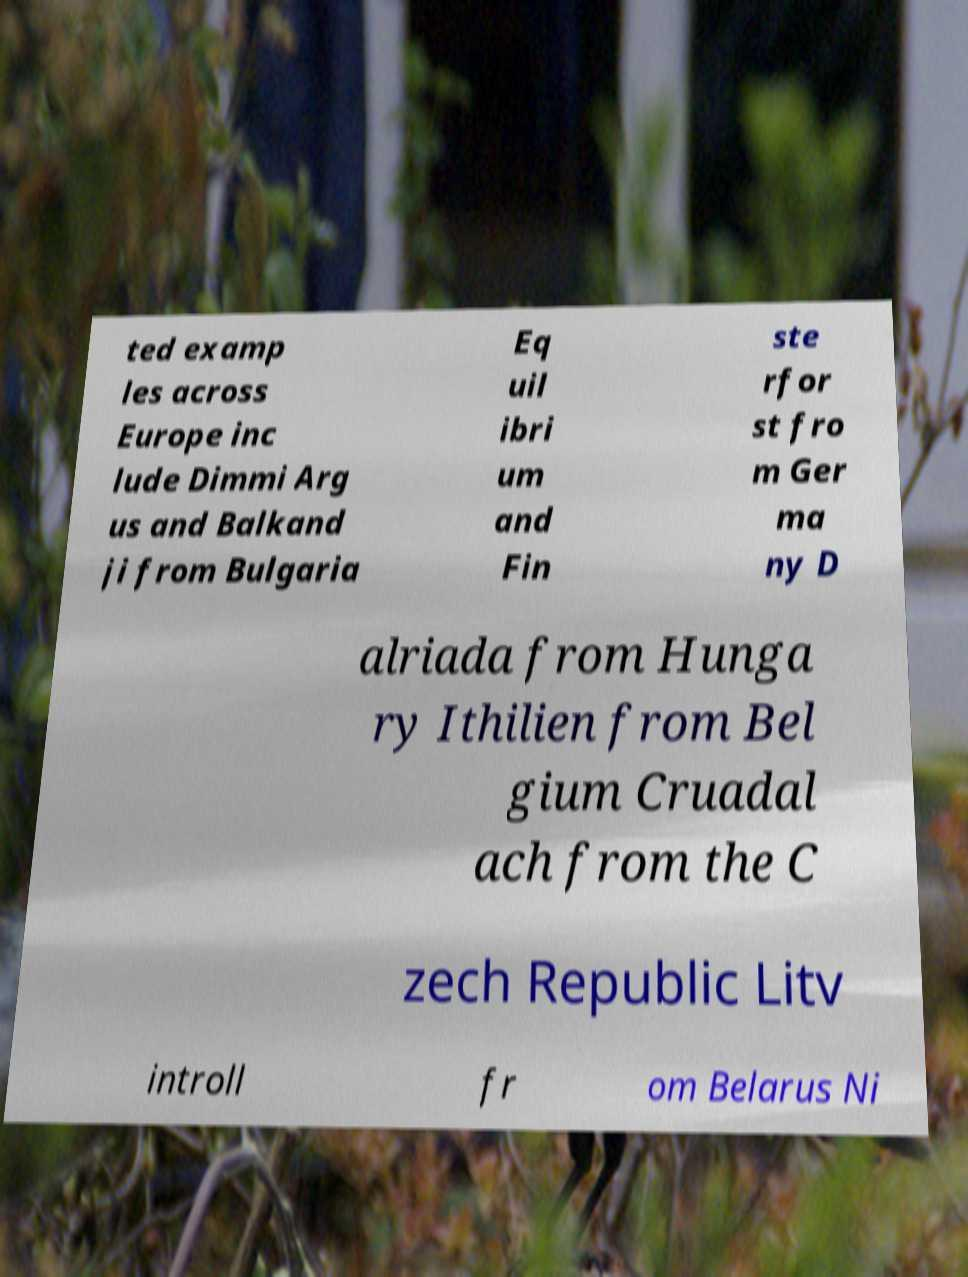For documentation purposes, I need the text within this image transcribed. Could you provide that? ted examp les across Europe inc lude Dimmi Arg us and Balkand ji from Bulgaria Eq uil ibri um and Fin ste rfor st fro m Ger ma ny D alriada from Hunga ry Ithilien from Bel gium Cruadal ach from the C zech Republic Litv introll fr om Belarus Ni 